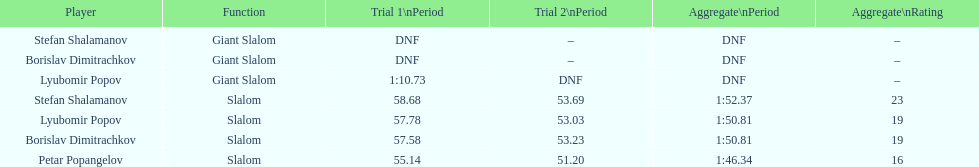Which athlete finished the first race but did not finish the second race? Lyubomir Popov. 